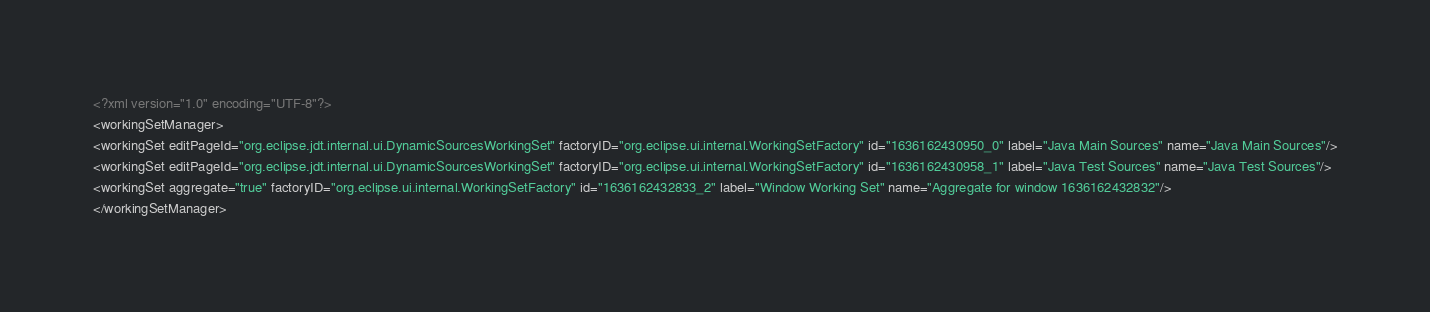Convert code to text. <code><loc_0><loc_0><loc_500><loc_500><_XML_><?xml version="1.0" encoding="UTF-8"?>
<workingSetManager>
<workingSet editPageId="org.eclipse.jdt.internal.ui.DynamicSourcesWorkingSet" factoryID="org.eclipse.ui.internal.WorkingSetFactory" id="1636162430950_0" label="Java Main Sources" name="Java Main Sources"/>
<workingSet editPageId="org.eclipse.jdt.internal.ui.DynamicSourcesWorkingSet" factoryID="org.eclipse.ui.internal.WorkingSetFactory" id="1636162430958_1" label="Java Test Sources" name="Java Test Sources"/>
<workingSet aggregate="true" factoryID="org.eclipse.ui.internal.WorkingSetFactory" id="1636162432833_2" label="Window Working Set" name="Aggregate for window 1636162432832"/>
</workingSetManager></code> 